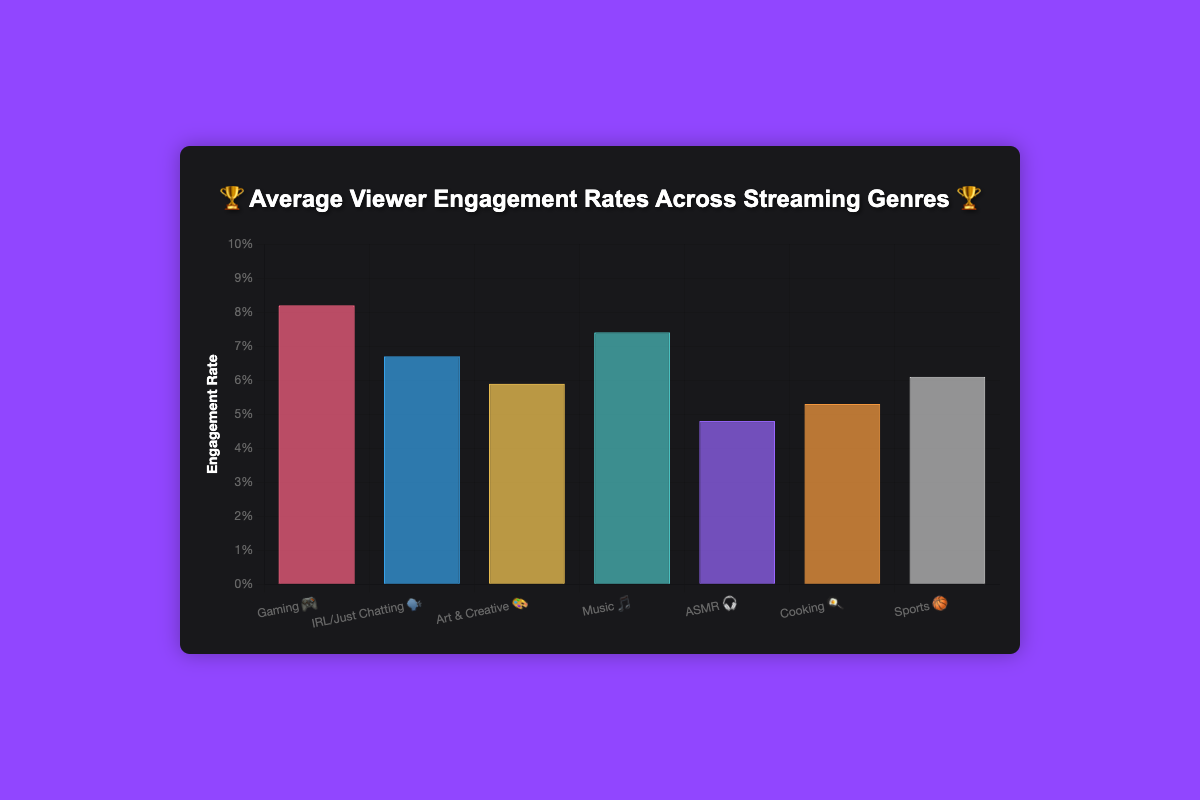what is the highest engagement rate genre? Look at the bars in the chart and compare their heights. The highest bar represents the genre with the highest engagement rate.
Answer: Gaming 🎮 which genre has the lowest engagement rate? Check the shortest bar in the chart, which shows the lowest engagement rate.
Answer: ASMR 🎧 how many genres have an engagement rate higher than 6%? Count all the bars whose heights surpass the 6% mark on the y-axis.
Answer: 5 what is the difference in engagement rate between Gaming 🎮 and Music 🎵? Find the bars representing Gaming and Music. Subtract the engagement rate of Music (7.4) from that of Gaming (8.2).
Answer: 0.8 Which genre has a higher engagement rate: Cooking 🍳 or Sports 🏀? Compare the heights of the bars for Cooking and Sports. The taller bar indicates the genre with a higher engagement rate.
Answer: Sports 🏀 what is the average engagement rate of IRL/Just Chatting 🗣️ and Art & Creative 🎨? Add the engagement rates of IRL/Just Chatting (6.7) and Art & Creative (5.9). Divide by 2.
Answer: 6.3 Are there more genres with engagement rates above 7% or below 7%? Count the bars above and below the 7% mark and compare the counts.
Answer: below 7% What's the total engagement rate for Cooking 🍳, Sports 🏀, and ASMR 🎧 combined? Add the engagement rates of Cooking (5.3), Sports (6.1), and ASMR (4.8).
Answer: 16.2 Which has a higher engagement rate, IRL/Just Chatting 🗣️ or Music 🎵? Compare the heights of the bars for IRL/Just Chatting and Music. The taller bar indicates the genre with a higher engagement rate.
Answer: Music 🎵 